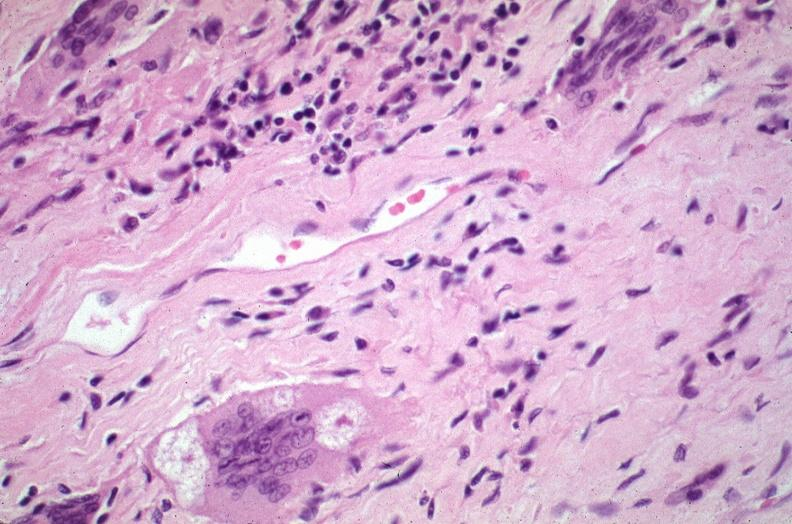s respiratory present?
Answer the question using a single word or phrase. Yes 